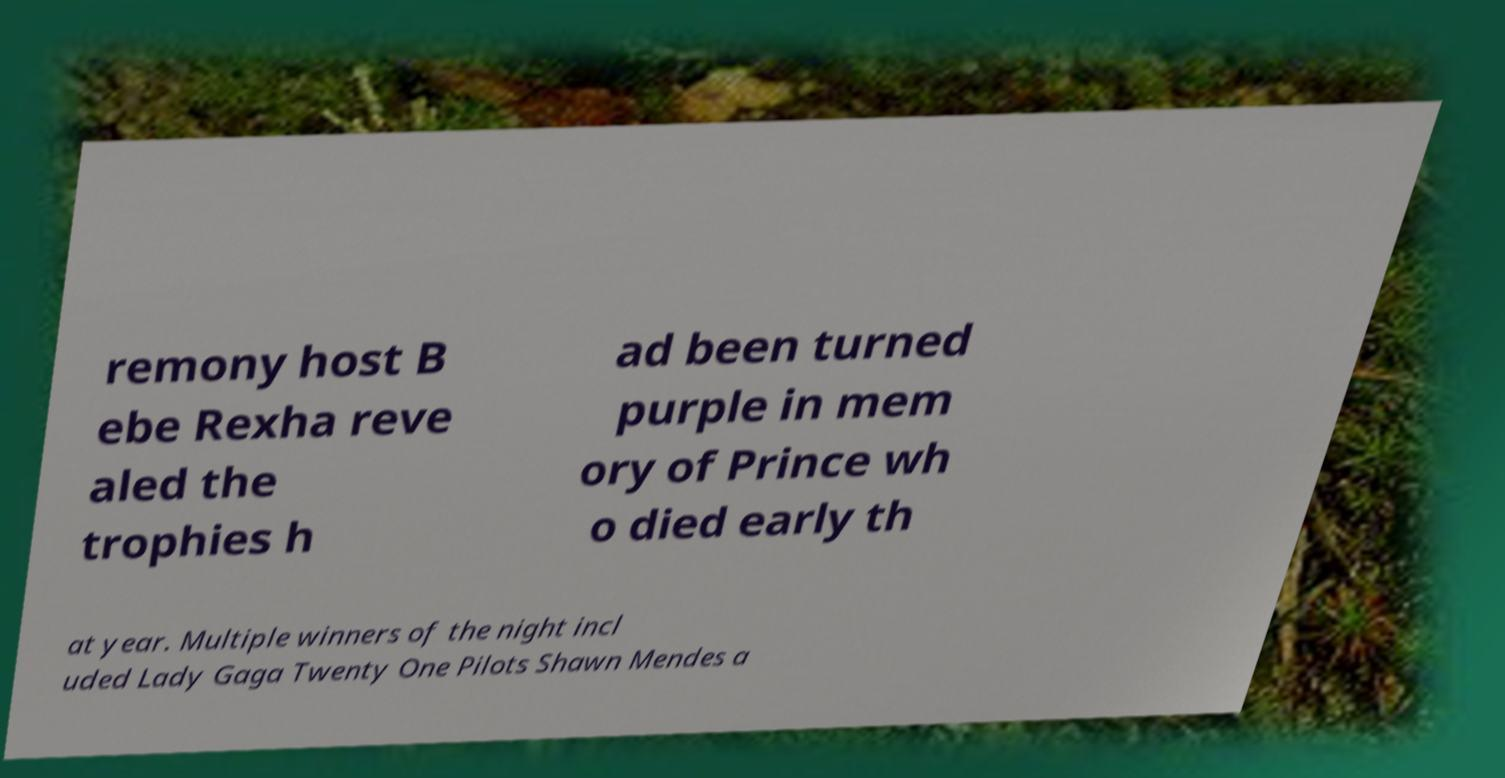Can you accurately transcribe the text from the provided image for me? remony host B ebe Rexha reve aled the trophies h ad been turned purple in mem ory of Prince wh o died early th at year. Multiple winners of the night incl uded Lady Gaga Twenty One Pilots Shawn Mendes a 